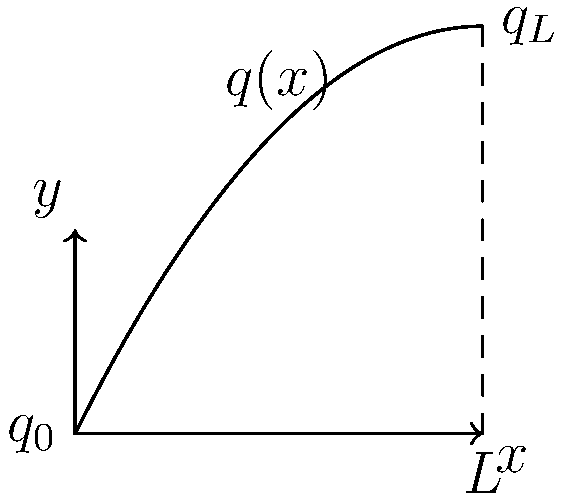A simply supported beam of length $L$ is subjected to a parabolic distributed load $q(x) = q_0 - \frac{q_0 - q_L}{L^2}x^2$, where $q_0$ and $q_L$ are the load intensities at $x=0$ and $x=L$, respectively. Determine the maximum bending moment in the beam. How does this compare to a uniformly distributed load of the same total magnitude? To solve this problem, we'll follow these steps:

1) First, we need to find the total load on the beam:
   $P = \int_0^L q(x) dx = \int_0^L (q_0 - \frac{q_0 - q_L}{L^2}x^2) dx$
   $P = q_0L - \frac{q_0 - q_L}{3L^2}L^3 = \frac{q_0 + q_L}{2}L$

2) The reactions at the supports will be:
   $R_A = R_B = \frac{P}{2} = \frac{q_0 + q_L}{4}L$

3) The bending moment at any point x is:
   $M(x) = R_A x - \int_0^x q(t)(x-t)dt$

4) After integration and simplification:
   $M(x) = \frac{q_0 + q_L}{4}Lx - q_0x^2/2 + \frac{q_0 - q_L}{6L^2}x^4$

5) To find the maximum bending moment, we differentiate M(x) and set it to zero:
   $\frac{dM}{dx} = \frac{q_0 + q_L}{4}L - q_0x + \frac{2(q_0 - q_L)}{3L^2}x^3 = 0$

6) This equation is satisfied when $x = L/2$, regardless of the values of $q_0$ and $q_L$.

7) The maximum bending moment occurs at $x = L/2$:
   $M_{max} = \frac{q_0 + q_L}{32}L^2$

8) For a uniformly distributed load of the same total magnitude:
   $q_{uniform} = \frac{P}{L} = \frac{q_0 + q_L}{2}$
   $M_{max,uniform} = \frac{q_{uniform}L^2}{8} = \frac{q_0 + q_L}{16}L^2$

9) Comparing the two:
   $\frac{M_{max,parabolic}}{M_{max,uniform}} = \frac{1/32}{1/16} = 0.5$

Therefore, the maximum bending moment for the parabolic load is half that of the equivalent uniform load.
Answer: $M_{max} = \frac{q_0 + q_L}{32}L^2$, which is 50% of the equivalent uniform load's maximum moment. 